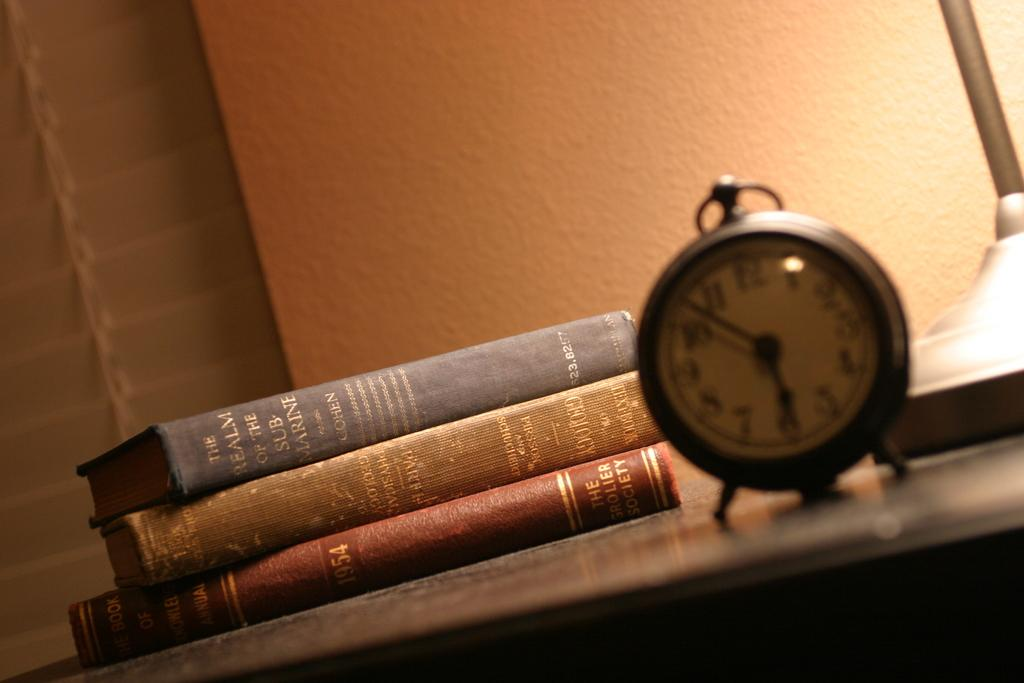<image>
Relay a brief, clear account of the picture shown. An old fashioned alarm clock is on a table in front of several books including "The Realm of the Submarines". 